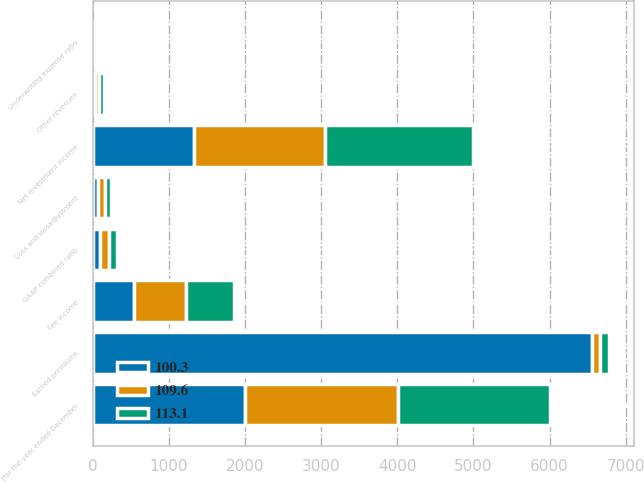<chart> <loc_0><loc_0><loc_500><loc_500><stacked_bar_chart><ecel><fcel>(for the year ended December<fcel>Earned premiums<fcel>Net investment income<fcel>Fee income<fcel>Other revenues<fcel>Loss and lossadjustment<fcel>Underwriting expense ratio<fcel>GAAP combined ratio<nl><fcel>113.1<fcel>2005<fcel>111.35<fcel>1944<fcel>629<fcel>55<fcel>83.6<fcel>29.5<fcel>113.1<nl><fcel>109.6<fcel>2004<fcel>111.35<fcel>1728<fcel>680<fcel>55<fcel>81.8<fcel>27.8<fcel>109.6<nl><fcel>100.3<fcel>2003<fcel>6552<fcel>1324<fcel>545<fcel>33<fcel>75.4<fcel>24.9<fcel>100.3<nl></chart> 